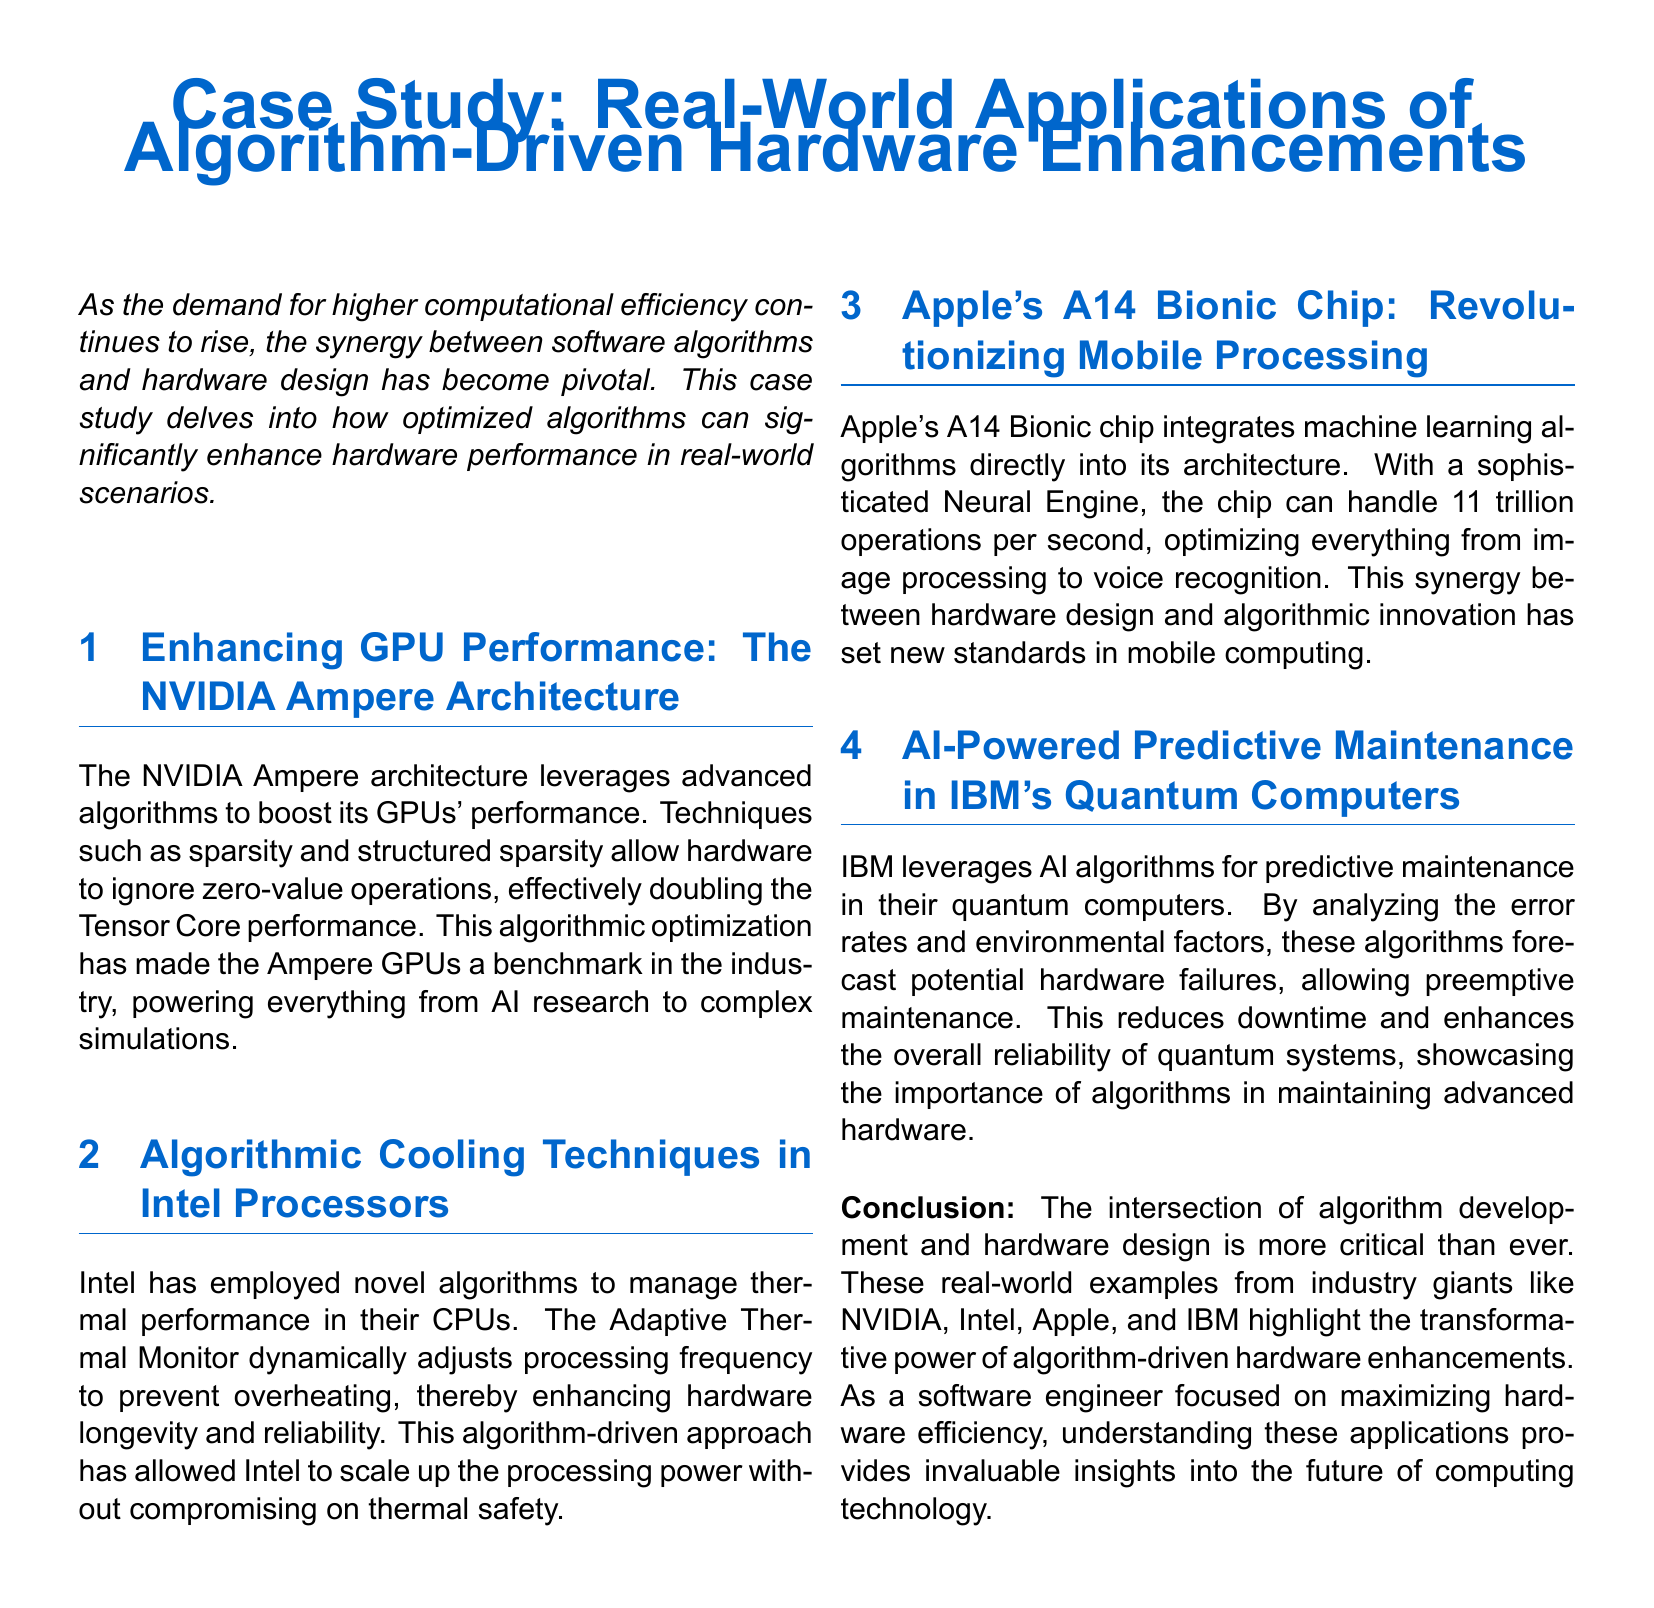What architecture does NVIDIA use for its GPUs? The document states that NVIDIA uses the Ampere architecture for its GPUs.
Answer: Ampere What unique feature does Intel’s Adaptive Thermal Monitor provide? The Adaptive Thermal Monitor dynamically adjusts processing frequency to prevent overheating.
Answer: Dynamic processing frequency adjustment How much processing capability does Apple's A14 Bionic chip have? The A14 Bionic chip can handle 11 trillion operations per second.
Answer: 11 trillion operations per second What is the primary function of AI algorithms in IBM's quantum computers? AI algorithms are used for predictive maintenance to forecast potential hardware failures.
Answer: Predictive maintenance Which company’s chip integrates a Neural Engine? The document mentions that Apple’s chip integrates a Neural Engine.
Answer: Apple What is the main benefit of algorithm-driven enhancements in hardware according to the conclusion? The conclusion states that algorithm-driven enhancements are critical for maximizing hardware efficiency.
Answer: Maximizing hardware efficiency How many sections are in the case study? The document contains four sections besides the conclusion and introduction.
Answer: Four sections What is the common theme discussed in the case study? The common theme is the synergy between software algorithms and hardware design to enhance performance.
Answer: Synergy between software algorithms and hardware design 